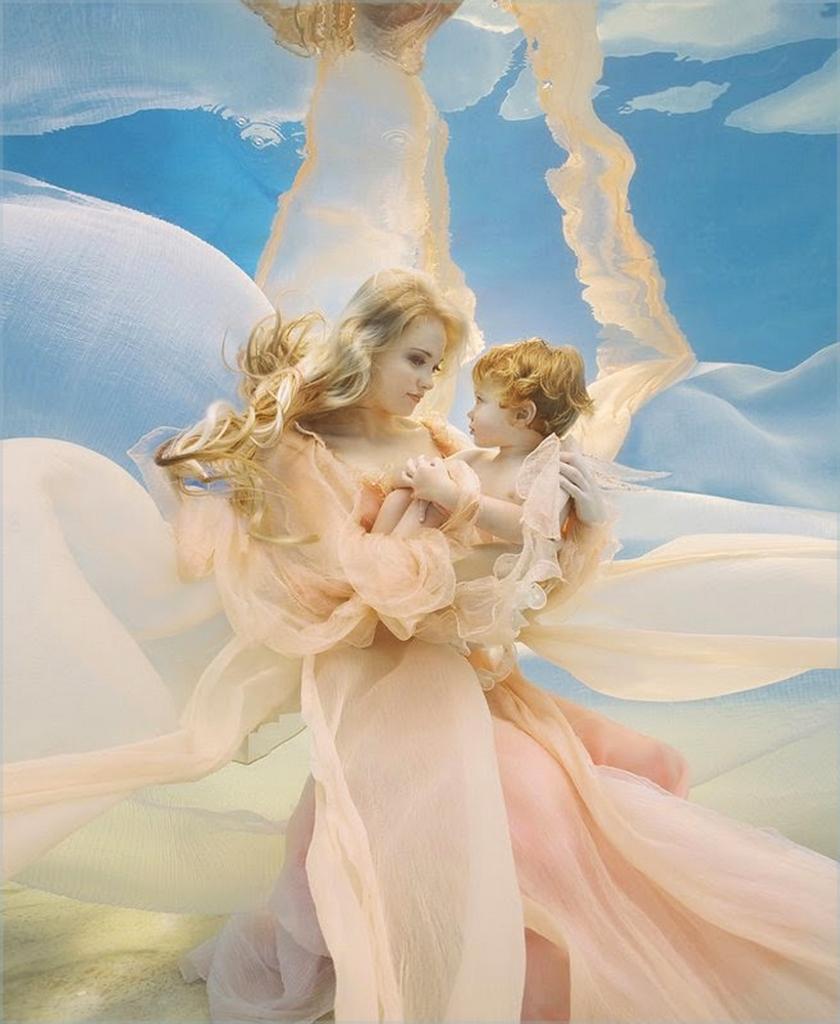Could you give a brief overview of what you see in this image? In the center of the image we can see a lady holding a baby. At the bottom there is sand. In the background there is sky. 